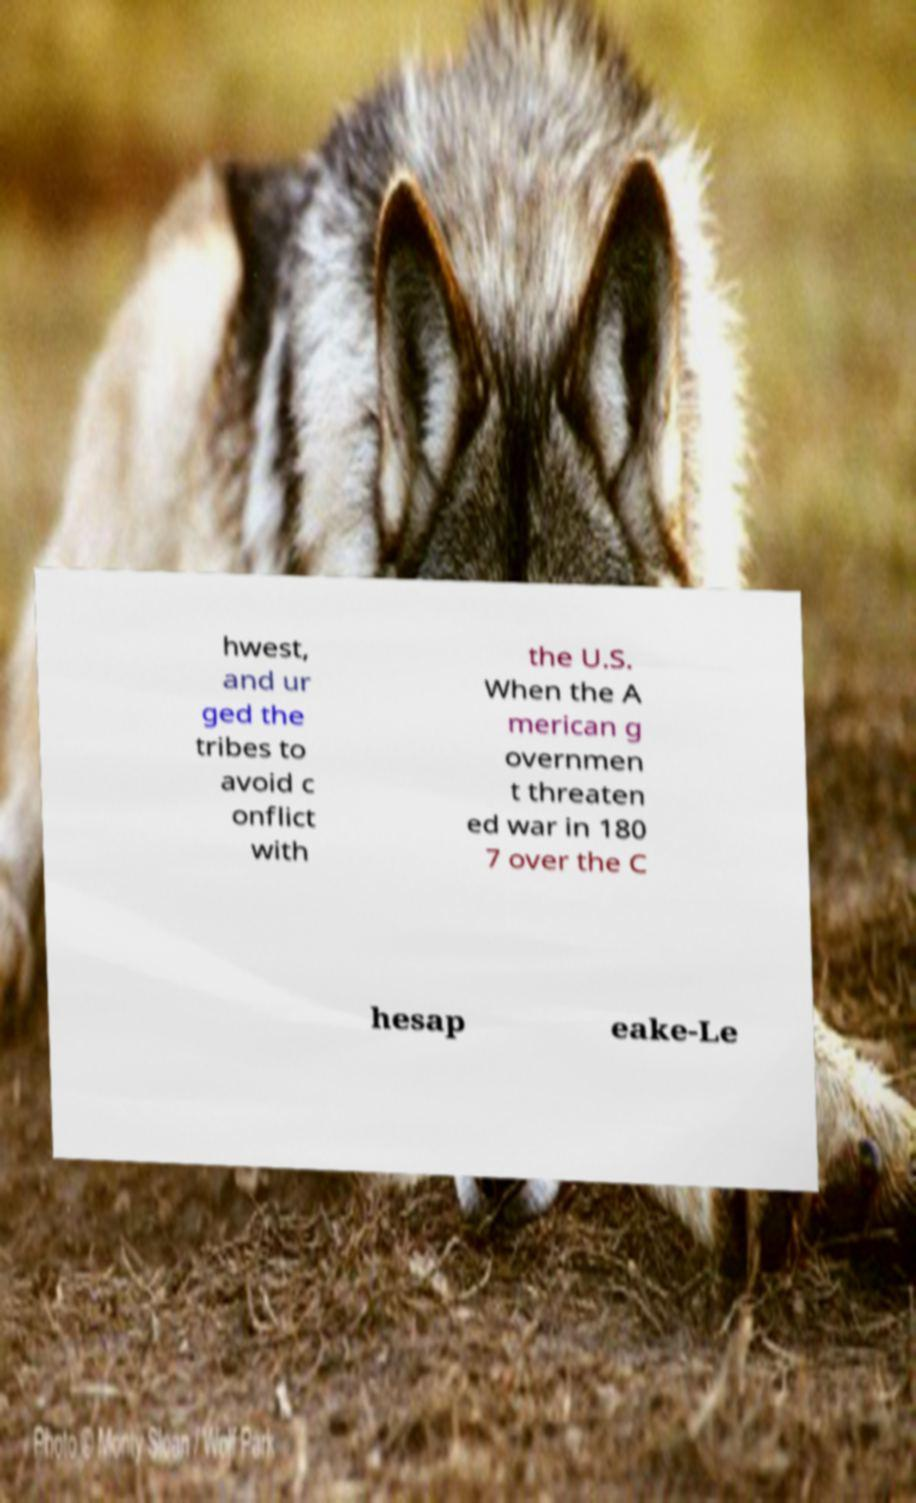Could you assist in decoding the text presented in this image and type it out clearly? hwest, and ur ged the tribes to avoid c onflict with the U.S. When the A merican g overnmen t threaten ed war in 180 7 over the C hesap eake-Le 